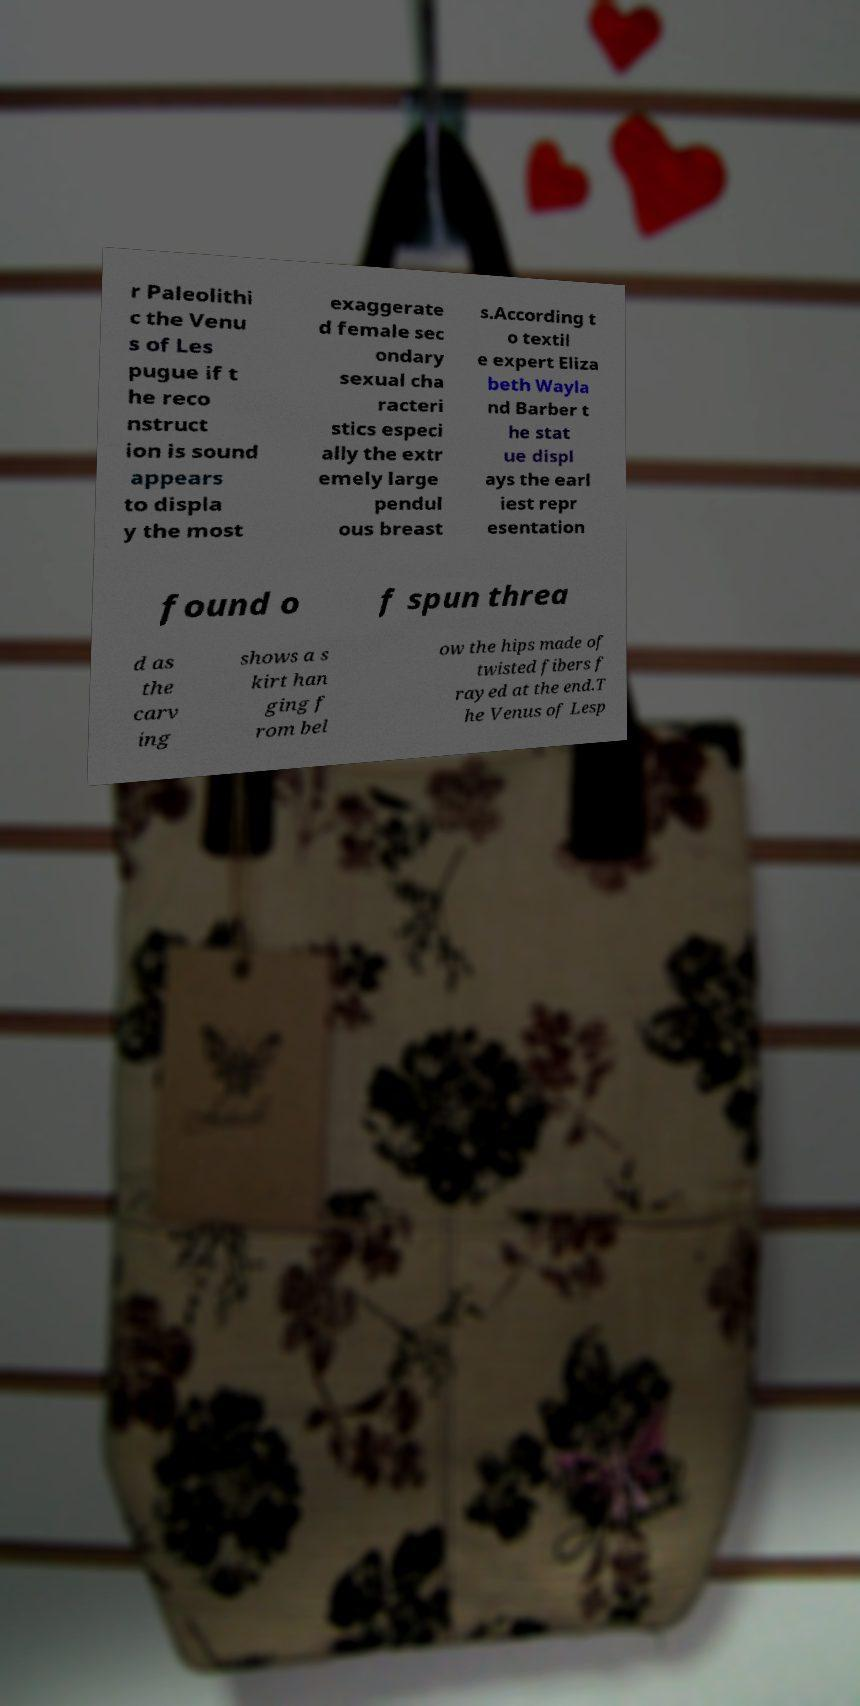Can you read and provide the text displayed in the image?This photo seems to have some interesting text. Can you extract and type it out for me? r Paleolithi c the Venu s of Les pugue if t he reco nstruct ion is sound appears to displa y the most exaggerate d female sec ondary sexual cha racteri stics especi ally the extr emely large pendul ous breast s.According t o textil e expert Eliza beth Wayla nd Barber t he stat ue displ ays the earl iest repr esentation found o f spun threa d as the carv ing shows a s kirt han ging f rom bel ow the hips made of twisted fibers f rayed at the end.T he Venus of Lesp 